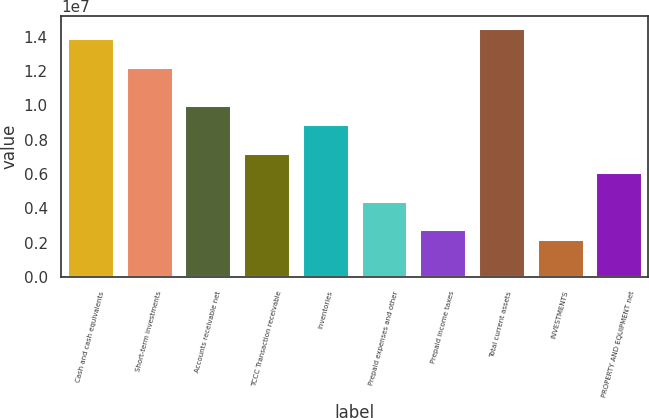Convert chart. <chart><loc_0><loc_0><loc_500><loc_500><bar_chart><fcel>Cash and cash equivalents<fcel>Short-term investments<fcel>Accounts receivable net<fcel>TCCC Transaction receivable<fcel>Inventories<fcel>Prepaid expenses and other<fcel>Prepaid income taxes<fcel>Total current assets<fcel>INVESTMENTS<fcel>PROPERTY AND EQUIPMENT net<nl><fcel>1.39241e+07<fcel>1.22535e+07<fcel>1.00261e+07<fcel>7.24184e+06<fcel>8.91239e+06<fcel>4.45757e+06<fcel>2.78701e+06<fcel>1.44809e+07<fcel>2.23016e+06<fcel>6.12813e+06<nl></chart> 